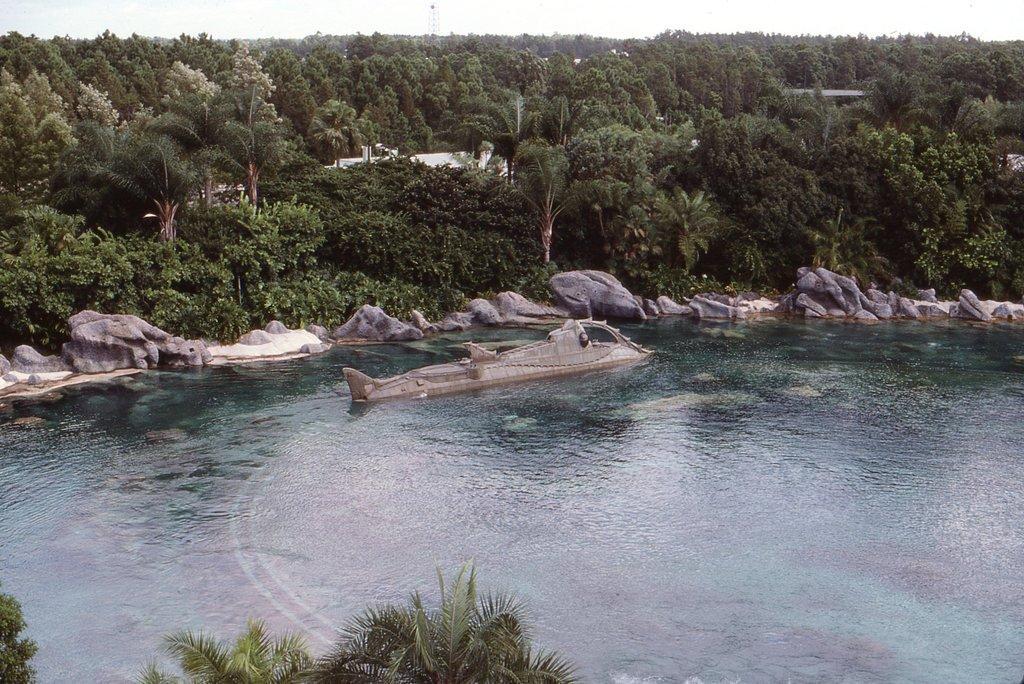Can you describe this image briefly? In this image we can see a lake and it looks like there is a ship in it, behind it there are rocks, trees, plants and houses, at the bottom of the image there are trees. 